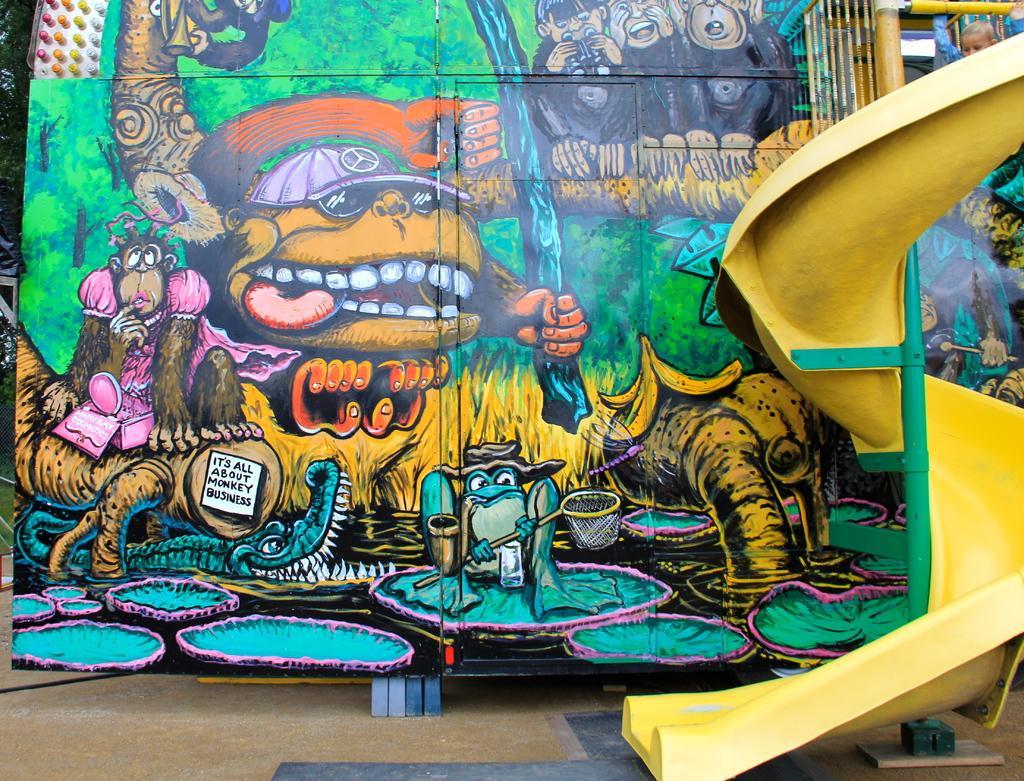How would you summarize this image in a sentence or two? In this image we can see the painting of few animals, trees and few objects. There is a slide in the image. There are few trees at the left side of the image. 